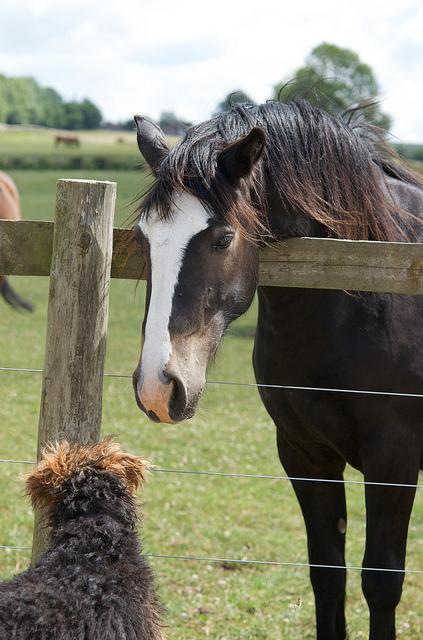This animal has a long what?
Make your selection from the four choices given to correctly answer the question.
Options: Stinger, face, wing, quill. Face. 